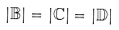Convert formula to latex. <formula><loc_0><loc_0><loc_500><loc_500>| \mathbb { B } | = | \mathbb { C } | = | \mathbb { D } |</formula> 